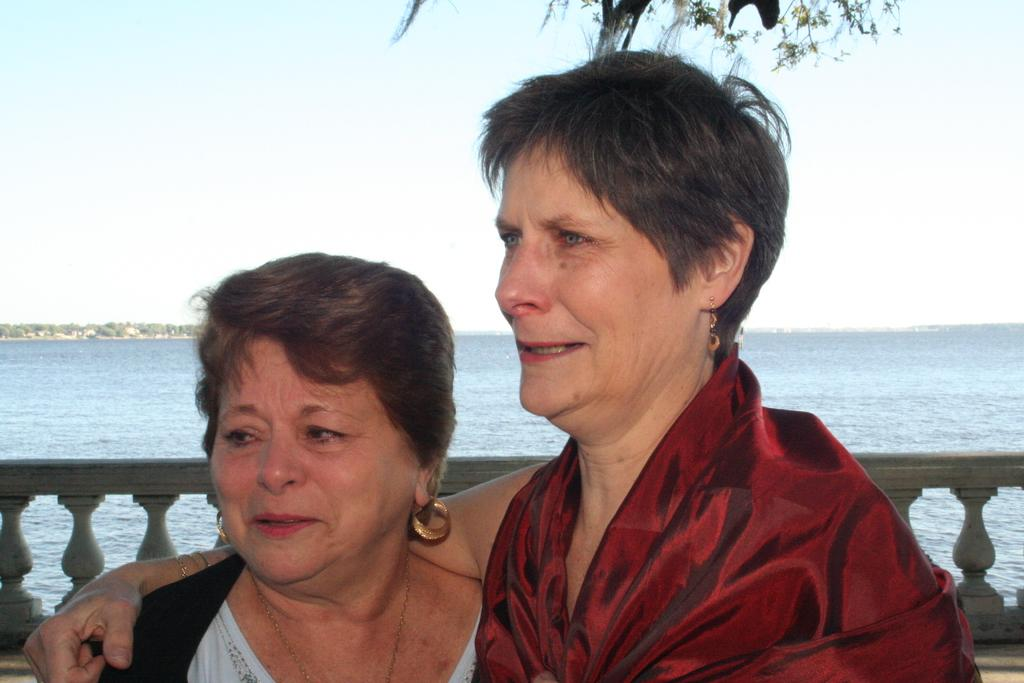How many people are present in the image? There are two persons in the image. What is located behind the people in the image? There is a wall in the image. What can be seen in the foreground of the image? There is water visible in the image. What type of natural environment is visible in the background of the image? Trees and the sky are visible in the background of the image. What type of club can be seen in the hands of the persons in the image? There is no club visible in the hands of the persons in the image. What is the needle used for in the image? There is no needle present in the image. 